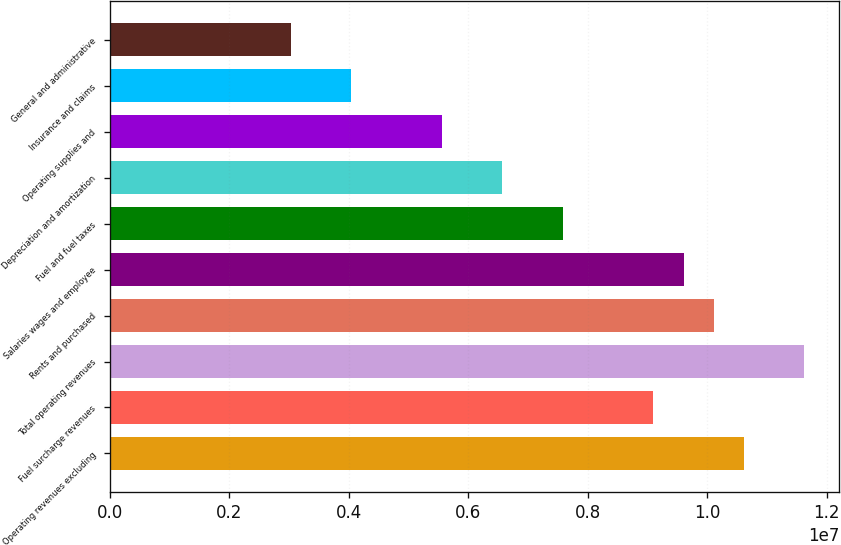Convert chart. <chart><loc_0><loc_0><loc_500><loc_500><bar_chart><fcel>Operating revenues excluding<fcel>Fuel surcharge revenues<fcel>Total operating revenues<fcel>Rents and purchased<fcel>Salaries wages and employee<fcel>Fuel and fuel taxes<fcel>Depreciation and amortization<fcel>Operating supplies and<fcel>Insurance and claims<fcel>General and administrative<nl><fcel>1.06155e+07<fcel>9.09896e+06<fcel>1.16265e+07<fcel>1.011e+07<fcel>9.60446e+06<fcel>7.58247e+06<fcel>6.57147e+06<fcel>5.56048e+06<fcel>4.04398e+06<fcel>3.03299e+06<nl></chart> 